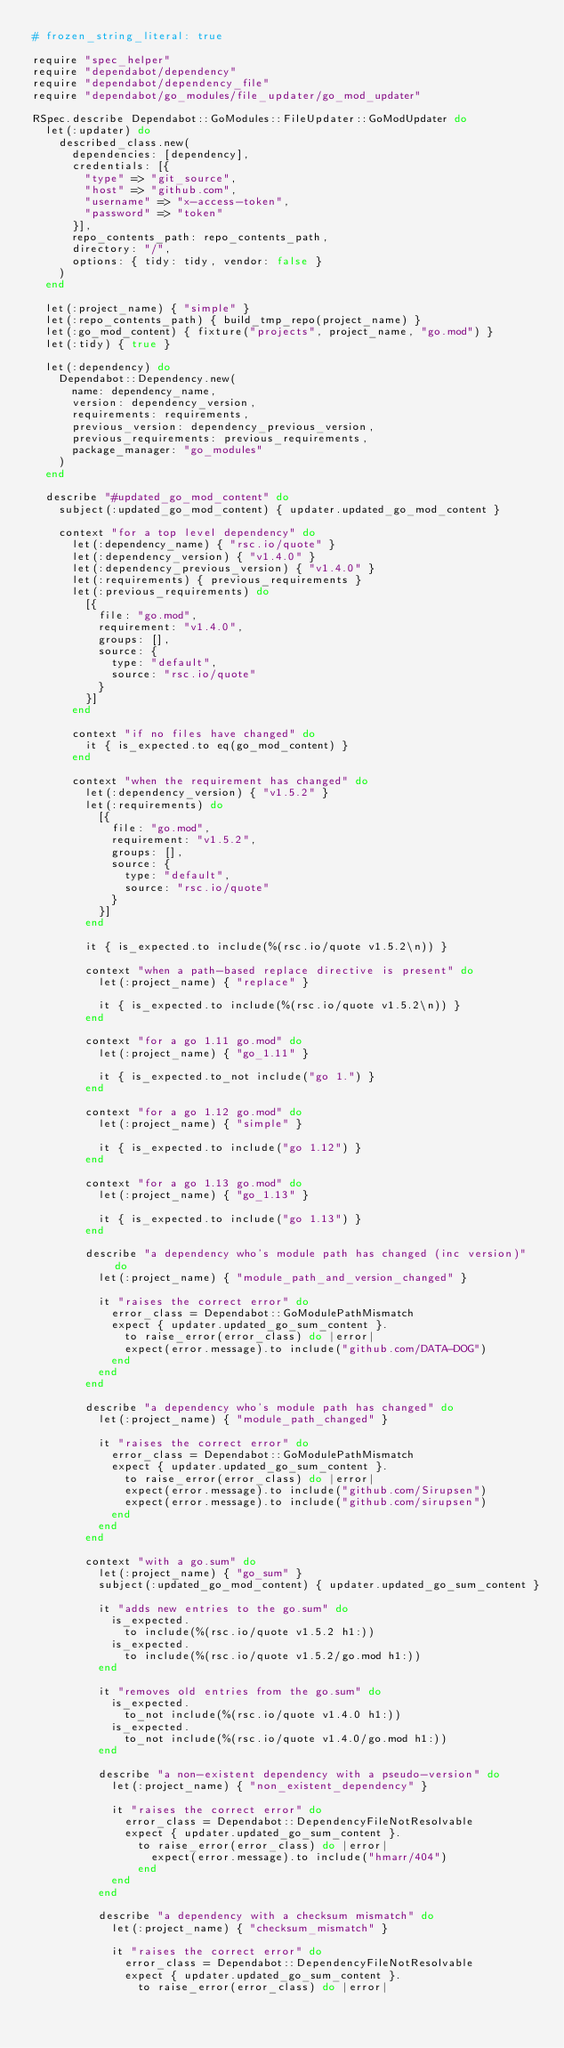Convert code to text. <code><loc_0><loc_0><loc_500><loc_500><_Ruby_># frozen_string_literal: true

require "spec_helper"
require "dependabot/dependency"
require "dependabot/dependency_file"
require "dependabot/go_modules/file_updater/go_mod_updater"

RSpec.describe Dependabot::GoModules::FileUpdater::GoModUpdater do
  let(:updater) do
    described_class.new(
      dependencies: [dependency],
      credentials: [{
        "type" => "git_source",
        "host" => "github.com",
        "username" => "x-access-token",
        "password" => "token"
      }],
      repo_contents_path: repo_contents_path,
      directory: "/",
      options: { tidy: tidy, vendor: false }
    )
  end

  let(:project_name) { "simple" }
  let(:repo_contents_path) { build_tmp_repo(project_name) }
  let(:go_mod_content) { fixture("projects", project_name, "go.mod") }
  let(:tidy) { true }

  let(:dependency) do
    Dependabot::Dependency.new(
      name: dependency_name,
      version: dependency_version,
      requirements: requirements,
      previous_version: dependency_previous_version,
      previous_requirements: previous_requirements,
      package_manager: "go_modules"
    )
  end

  describe "#updated_go_mod_content" do
    subject(:updated_go_mod_content) { updater.updated_go_mod_content }

    context "for a top level dependency" do
      let(:dependency_name) { "rsc.io/quote" }
      let(:dependency_version) { "v1.4.0" }
      let(:dependency_previous_version) { "v1.4.0" }
      let(:requirements) { previous_requirements }
      let(:previous_requirements) do
        [{
          file: "go.mod",
          requirement: "v1.4.0",
          groups: [],
          source: {
            type: "default",
            source: "rsc.io/quote"
          }
        }]
      end

      context "if no files have changed" do
        it { is_expected.to eq(go_mod_content) }
      end

      context "when the requirement has changed" do
        let(:dependency_version) { "v1.5.2" }
        let(:requirements) do
          [{
            file: "go.mod",
            requirement: "v1.5.2",
            groups: [],
            source: {
              type: "default",
              source: "rsc.io/quote"
            }
          }]
        end

        it { is_expected.to include(%(rsc.io/quote v1.5.2\n)) }

        context "when a path-based replace directive is present" do
          let(:project_name) { "replace" }

          it { is_expected.to include(%(rsc.io/quote v1.5.2\n)) }
        end

        context "for a go 1.11 go.mod" do
          let(:project_name) { "go_1.11" }

          it { is_expected.to_not include("go 1.") }
        end

        context "for a go 1.12 go.mod" do
          let(:project_name) { "simple" }

          it { is_expected.to include("go 1.12") }
        end

        context "for a go 1.13 go.mod" do
          let(:project_name) { "go_1.13" }

          it { is_expected.to include("go 1.13") }
        end

        describe "a dependency who's module path has changed (inc version)" do
          let(:project_name) { "module_path_and_version_changed" }

          it "raises the correct error" do
            error_class = Dependabot::GoModulePathMismatch
            expect { updater.updated_go_sum_content }.
              to raise_error(error_class) do |error|
              expect(error.message).to include("github.com/DATA-DOG")
            end
          end
        end

        describe "a dependency who's module path has changed" do
          let(:project_name) { "module_path_changed" }

          it "raises the correct error" do
            error_class = Dependabot::GoModulePathMismatch
            expect { updater.updated_go_sum_content }.
              to raise_error(error_class) do |error|
              expect(error.message).to include("github.com/Sirupsen")
              expect(error.message).to include("github.com/sirupsen")
            end
          end
        end

        context "with a go.sum" do
          let(:project_name) { "go_sum" }
          subject(:updated_go_mod_content) { updater.updated_go_sum_content }

          it "adds new entries to the go.sum" do
            is_expected.
              to include(%(rsc.io/quote v1.5.2 h1:))
            is_expected.
              to include(%(rsc.io/quote v1.5.2/go.mod h1:))
          end

          it "removes old entries from the go.sum" do
            is_expected.
              to_not include(%(rsc.io/quote v1.4.0 h1:))
            is_expected.
              to_not include(%(rsc.io/quote v1.4.0/go.mod h1:))
          end

          describe "a non-existent dependency with a pseudo-version" do
            let(:project_name) { "non_existent_dependency" }

            it "raises the correct error" do
              error_class = Dependabot::DependencyFileNotResolvable
              expect { updater.updated_go_sum_content }.
                to raise_error(error_class) do |error|
                  expect(error.message).to include("hmarr/404")
                end
            end
          end

          describe "a dependency with a checksum mismatch" do
            let(:project_name) { "checksum_mismatch" }

            it "raises the correct error" do
              error_class = Dependabot::DependencyFileNotResolvable
              expect { updater.updated_go_sum_content }.
                to raise_error(error_class) do |error|</code> 